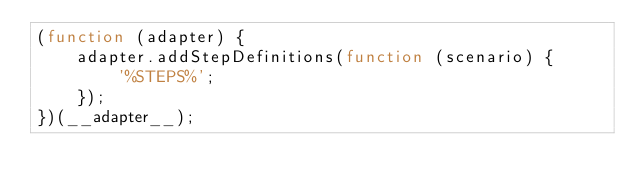<code> <loc_0><loc_0><loc_500><loc_500><_JavaScript_>(function (adapter) {
    adapter.addStepDefinitions(function (scenario) {
        '%STEPS%';
    });
})(__adapter__);
</code> 